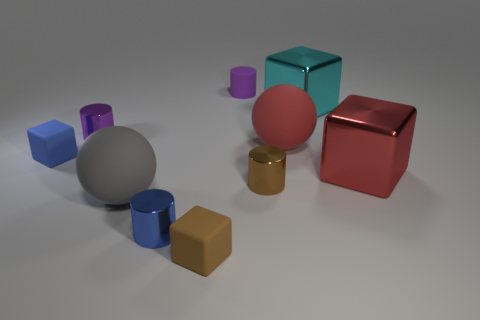There is a rubber sphere that is in front of the tiny blue rubber thing; does it have the same size as the matte ball right of the small brown metallic object?
Provide a short and direct response. Yes. There is a brown thing in front of the brown metal cylinder; what shape is it?
Provide a short and direct response. Cube. There is a small purple cylinder left of the small thing behind the big cyan shiny thing; what is its material?
Provide a short and direct response. Metal. Are there any small objects that have the same color as the small matte cylinder?
Give a very brief answer. Yes. Is the size of the gray sphere the same as the purple cylinder that is to the right of the big gray sphere?
Offer a terse response. No. There is a small blue thing that is behind the large metal cube that is in front of the large red rubber object; how many rubber things are to the right of it?
Provide a short and direct response. 4. How many big balls are to the left of the red metallic thing?
Give a very brief answer. 2. What is the color of the tiny metal object that is behind the large red metal object in front of the cyan cube?
Provide a succinct answer. Purple. How many other objects are there of the same material as the brown block?
Provide a succinct answer. 4. Is the number of big things that are in front of the gray object the same as the number of tiny gray shiny cylinders?
Offer a very short reply. Yes. 